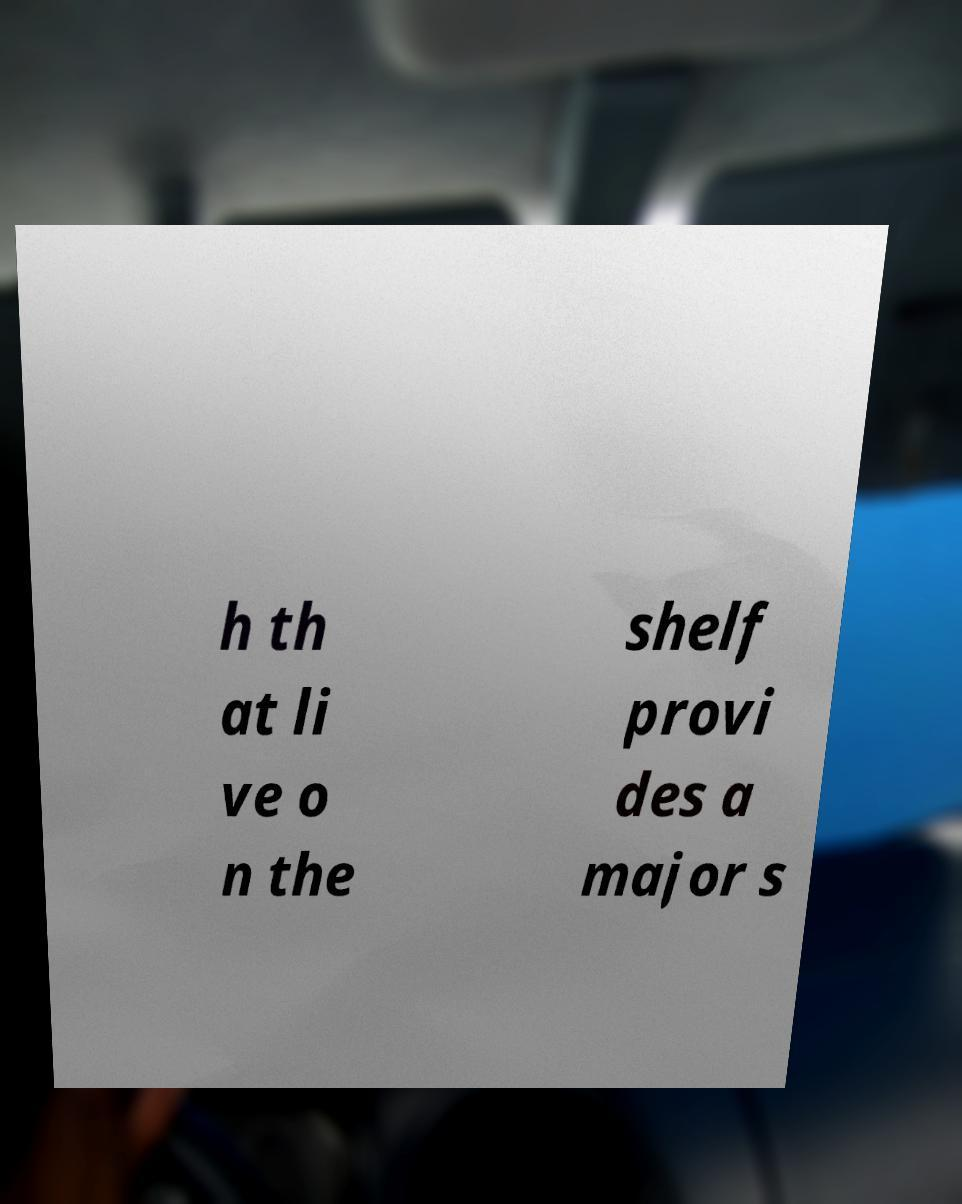What messages or text are displayed in this image? I need them in a readable, typed format. h th at li ve o n the shelf provi des a major s 